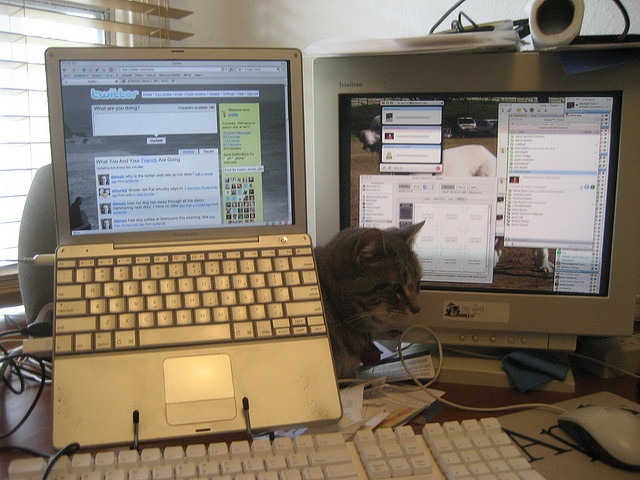Describe the objects in this image and their specific colors. I can see laptop in darkgray, tan, and gray tones, tv in darkgray, black, lightgray, and maroon tones, keyboard in darkgray, gray, and tan tones, cat in darkgray, black, maroon, and gray tones, and mouse in darkgray, gray, and black tones in this image. 